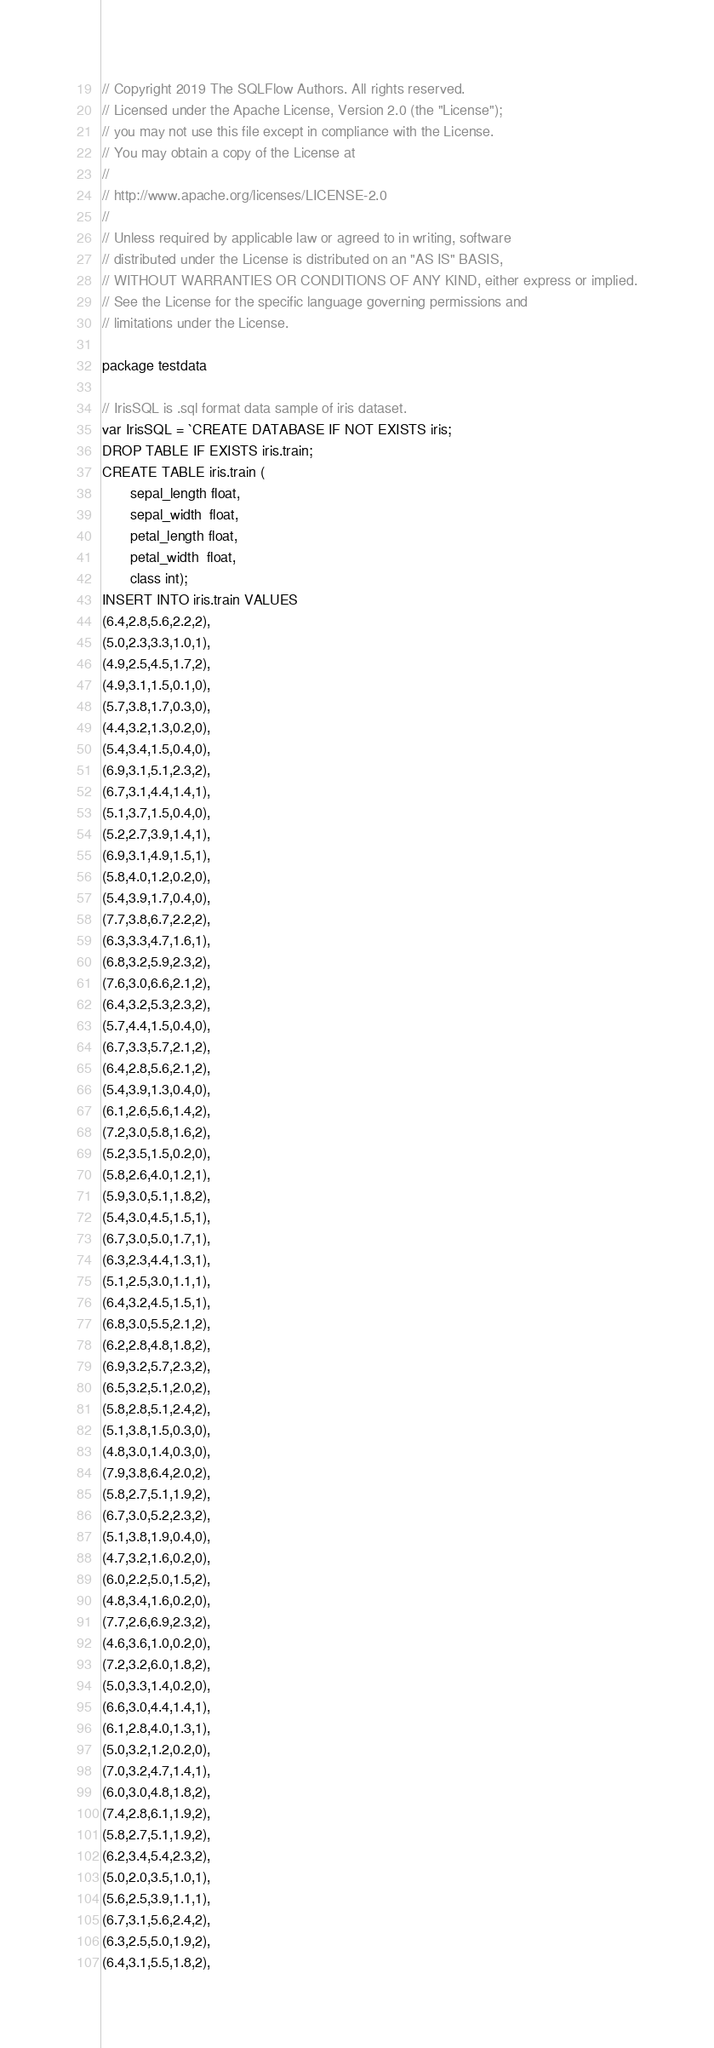Convert code to text. <code><loc_0><loc_0><loc_500><loc_500><_Go_>// Copyright 2019 The SQLFlow Authors. All rights reserved.
// Licensed under the Apache License, Version 2.0 (the "License");
// you may not use this file except in compliance with the License.
// You may obtain a copy of the License at
//
// http://www.apache.org/licenses/LICENSE-2.0
//
// Unless required by applicable law or agreed to in writing, software
// distributed under the License is distributed on an "AS IS" BASIS,
// WITHOUT WARRANTIES OR CONDITIONS OF ANY KIND, either express or implied.
// See the License for the specific language governing permissions and
// limitations under the License.

package testdata

// IrisSQL is .sql format data sample of iris dataset.
var IrisSQL = `CREATE DATABASE IF NOT EXISTS iris;
DROP TABLE IF EXISTS iris.train;
CREATE TABLE iris.train (
       sepal_length float,
       sepal_width  float,
       petal_length float,
       petal_width  float,
       class int);
INSERT INTO iris.train VALUES
(6.4,2.8,5.6,2.2,2),
(5.0,2.3,3.3,1.0,1),
(4.9,2.5,4.5,1.7,2),
(4.9,3.1,1.5,0.1,0),
(5.7,3.8,1.7,0.3,0),
(4.4,3.2,1.3,0.2,0),
(5.4,3.4,1.5,0.4,0),
(6.9,3.1,5.1,2.3,2),
(6.7,3.1,4.4,1.4,1),
(5.1,3.7,1.5,0.4,0),
(5.2,2.7,3.9,1.4,1),
(6.9,3.1,4.9,1.5,1),
(5.8,4.0,1.2,0.2,0),
(5.4,3.9,1.7,0.4,0),
(7.7,3.8,6.7,2.2,2),
(6.3,3.3,4.7,1.6,1),
(6.8,3.2,5.9,2.3,2),
(7.6,3.0,6.6,2.1,2),
(6.4,3.2,5.3,2.3,2),
(5.7,4.4,1.5,0.4,0),
(6.7,3.3,5.7,2.1,2),
(6.4,2.8,5.6,2.1,2),
(5.4,3.9,1.3,0.4,0),
(6.1,2.6,5.6,1.4,2),
(7.2,3.0,5.8,1.6,2),
(5.2,3.5,1.5,0.2,0),
(5.8,2.6,4.0,1.2,1),
(5.9,3.0,5.1,1.8,2),
(5.4,3.0,4.5,1.5,1),
(6.7,3.0,5.0,1.7,1),
(6.3,2.3,4.4,1.3,1),
(5.1,2.5,3.0,1.1,1),
(6.4,3.2,4.5,1.5,1),
(6.8,3.0,5.5,2.1,2),
(6.2,2.8,4.8,1.8,2),
(6.9,3.2,5.7,2.3,2),
(6.5,3.2,5.1,2.0,2),
(5.8,2.8,5.1,2.4,2),
(5.1,3.8,1.5,0.3,0),
(4.8,3.0,1.4,0.3,0),
(7.9,3.8,6.4,2.0,2),
(5.8,2.7,5.1,1.9,2),
(6.7,3.0,5.2,2.3,2),
(5.1,3.8,1.9,0.4,0),
(4.7,3.2,1.6,0.2,0),
(6.0,2.2,5.0,1.5,2),
(4.8,3.4,1.6,0.2,0),
(7.7,2.6,6.9,2.3,2),
(4.6,3.6,1.0,0.2,0),
(7.2,3.2,6.0,1.8,2),
(5.0,3.3,1.4,0.2,0),
(6.6,3.0,4.4,1.4,1),
(6.1,2.8,4.0,1.3,1),
(5.0,3.2,1.2,0.2,0),
(7.0,3.2,4.7,1.4,1),
(6.0,3.0,4.8,1.8,2),
(7.4,2.8,6.1,1.9,2),
(5.8,2.7,5.1,1.9,2),
(6.2,3.4,5.4,2.3,2),
(5.0,2.0,3.5,1.0,1),
(5.6,2.5,3.9,1.1,1),
(6.7,3.1,5.6,2.4,2),
(6.3,2.5,5.0,1.9,2),
(6.4,3.1,5.5,1.8,2),</code> 